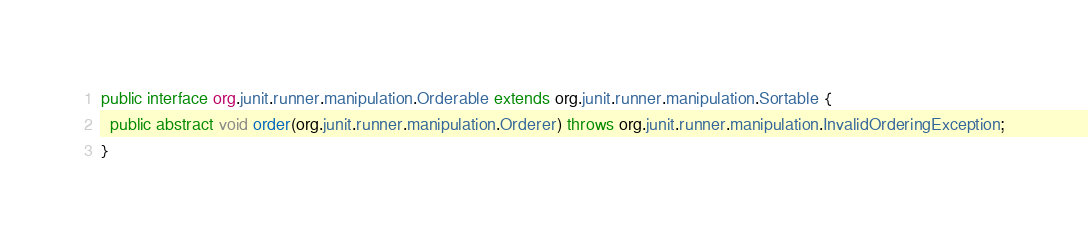<code> <loc_0><loc_0><loc_500><loc_500><_Java_>public interface org.junit.runner.manipulation.Orderable extends org.junit.runner.manipulation.Sortable {
  public abstract void order(org.junit.runner.manipulation.Orderer) throws org.junit.runner.manipulation.InvalidOrderingException;
}
</code> 